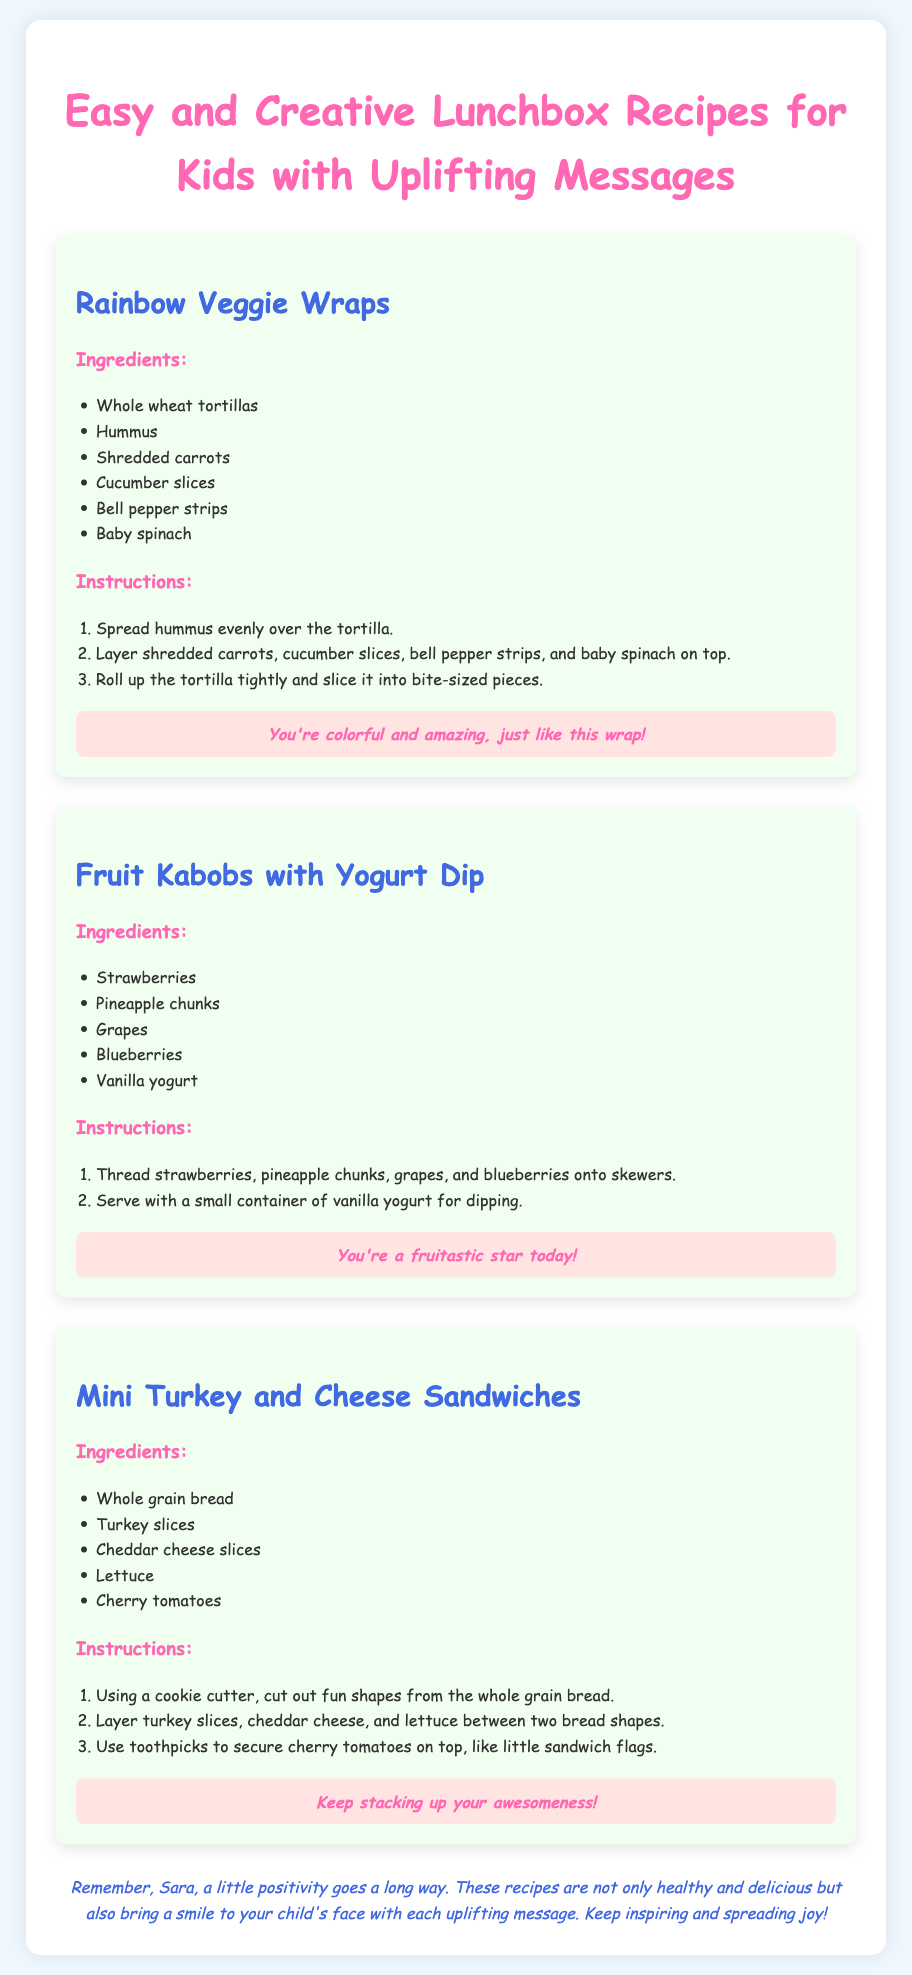what is the first recipe listed? The first recipe mentioned in the document is "Rainbow Veggie Wraps".
Answer: Rainbow Veggie Wraps how many ingredients are listed for the Fruit Kabobs with Yogurt Dip? The recipe for Fruit Kabobs with Yogurt Dip lists five ingredients.
Answer: five what uplifting message is associated with the Mini Turkey and Cheese Sandwiches? The uplifting message for Mini Turkey and Cheese Sandwiches is "Keep stacking up your awesomeness!".
Answer: Keep stacking up your awesomeness! which ingredient is used in all three recipes? Hummus is used in the Rainbow Veggie Wraps and the Fruit Kabobs with Yogurt Dip, while turkey is a key ingredient in the Mini Turkey and Cheese Sandwiches.
Answer: none what is the main vegetable component in the Rainbow Veggie Wraps? The main vegetable components include shredded carrots, cucumber slices, bell pepper strips, and baby spinach.
Answer: shredded carrots, cucumber slices, bell pepper strips, baby spinach how are the ingredients prepared for the Fruit Kabobs? The ingredients for the Fruit Kabobs are threaded onto skewers.
Answer: threaded onto skewers what type of bread is used for the Mini Turkey and Cheese Sandwiches? The type of bread used in the Mini Turkey and Cheese Sandwiches is whole grain bread.
Answer: whole grain bread how does the document encourage positivity? The document includes uplifting messages with each recipe, promoting a fun and positive atmosphere for kids.
Answer: uplifting messages 